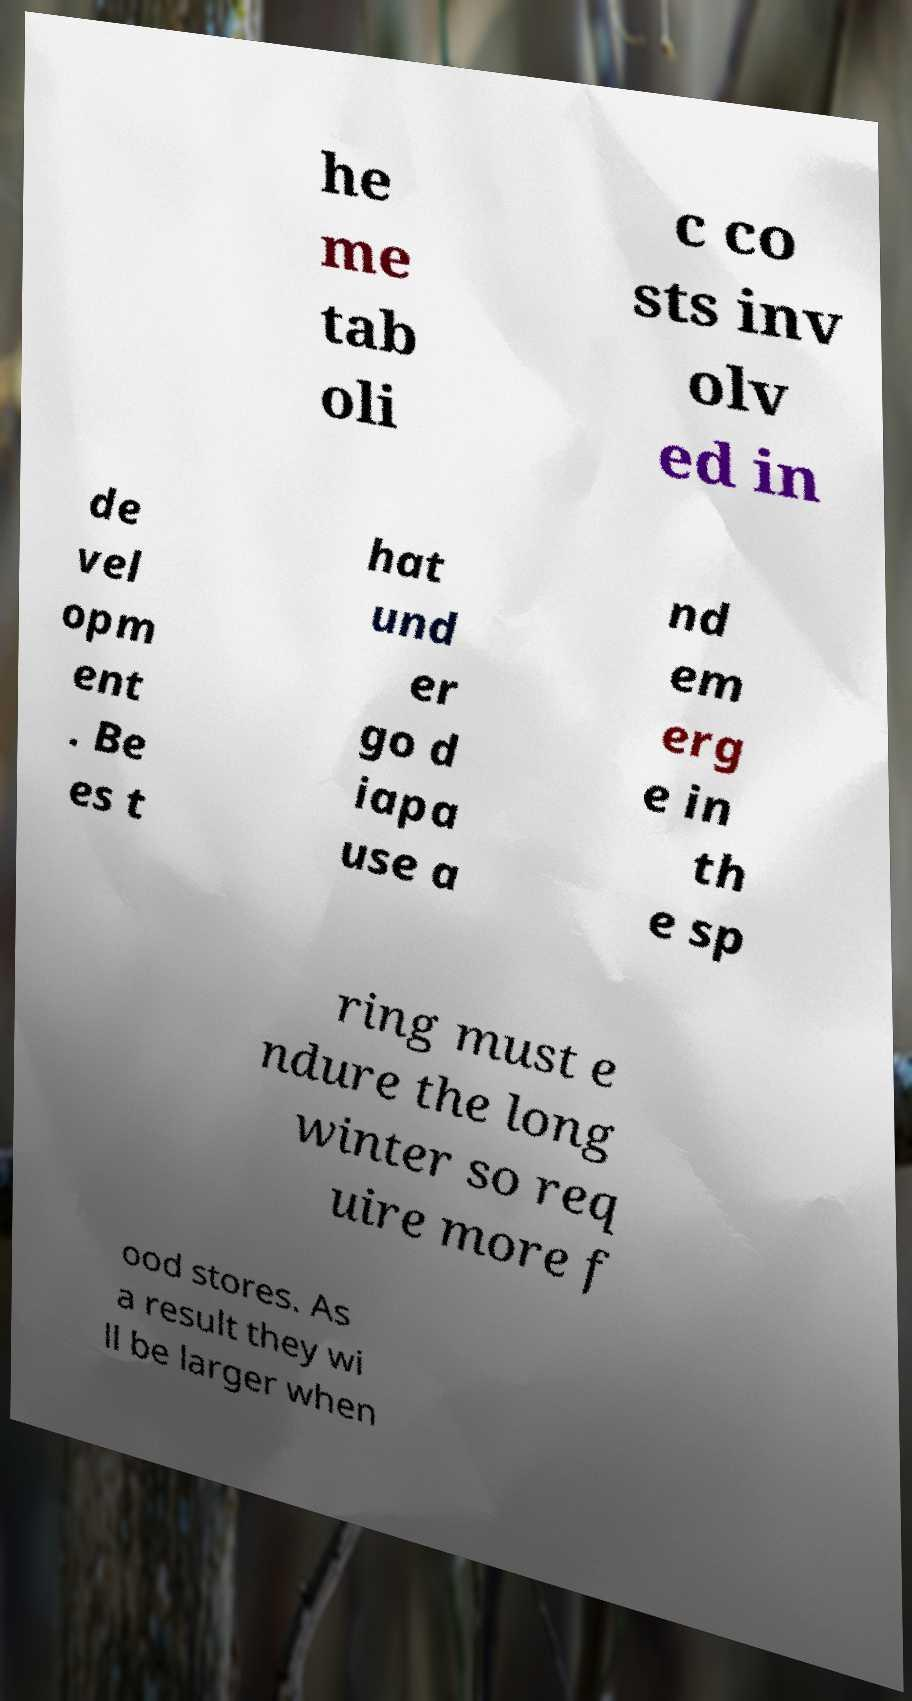Please identify and transcribe the text found in this image. he me tab oli c co sts inv olv ed in de vel opm ent . Be es t hat und er go d iapa use a nd em erg e in th e sp ring must e ndure the long winter so req uire more f ood stores. As a result they wi ll be larger when 